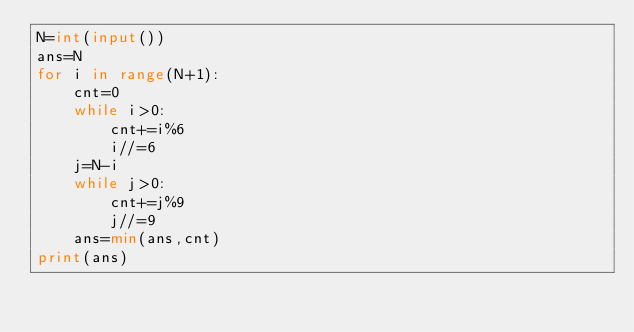Convert code to text. <code><loc_0><loc_0><loc_500><loc_500><_Python_>N=int(input())
ans=N
for i in range(N+1):
    cnt=0
    while i>0:
        cnt+=i%6
        i//=6
    j=N-i
    while j>0:
        cnt+=j%9
        j//=9
    ans=min(ans,cnt)
print(ans)</code> 